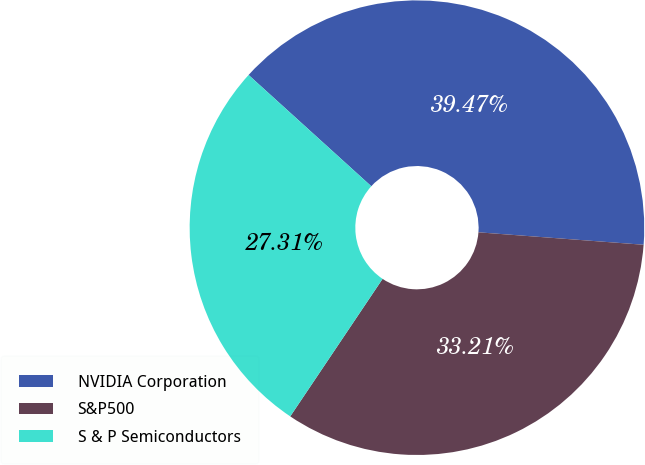<chart> <loc_0><loc_0><loc_500><loc_500><pie_chart><fcel>NVIDIA Corporation<fcel>S&P500<fcel>S & P Semiconductors<nl><fcel>39.47%<fcel>33.21%<fcel>27.31%<nl></chart> 